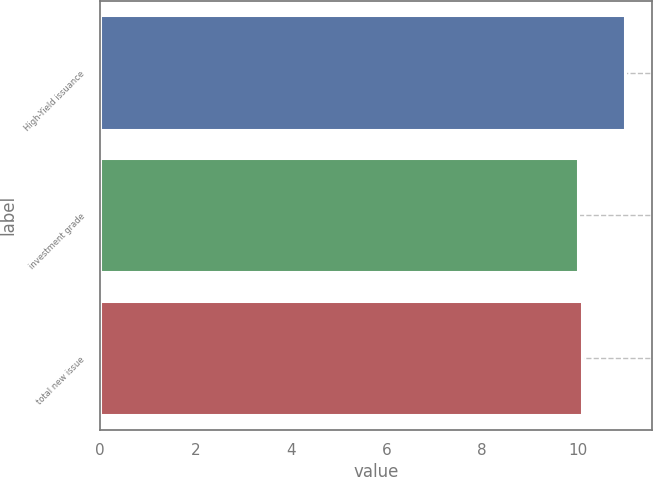Convert chart to OTSL. <chart><loc_0><loc_0><loc_500><loc_500><bar_chart><fcel>High-Yield issuance<fcel>investment grade<fcel>total new issue<nl><fcel>11<fcel>10<fcel>10.1<nl></chart> 